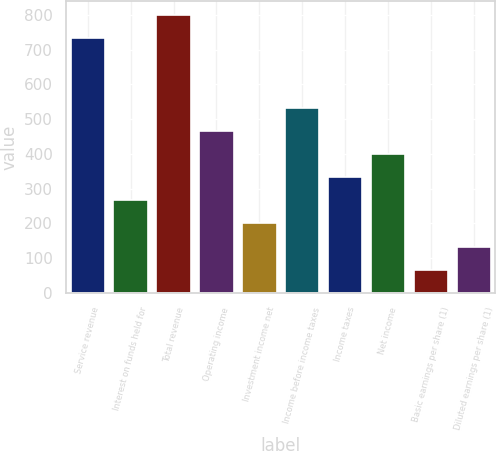Convert chart. <chart><loc_0><loc_0><loc_500><loc_500><bar_chart><fcel>Service revenue<fcel>Interest on funds held for<fcel>Total revenue<fcel>Operating income<fcel>Investment income net<fcel>Income before income taxes<fcel>Income taxes<fcel>Net income<fcel>Basic earnings per share (1)<fcel>Diluted earnings per share (1)<nl><fcel>733.42<fcel>266.94<fcel>800.06<fcel>466.86<fcel>200.3<fcel>533.5<fcel>333.58<fcel>400.22<fcel>67.02<fcel>133.66<nl></chart> 